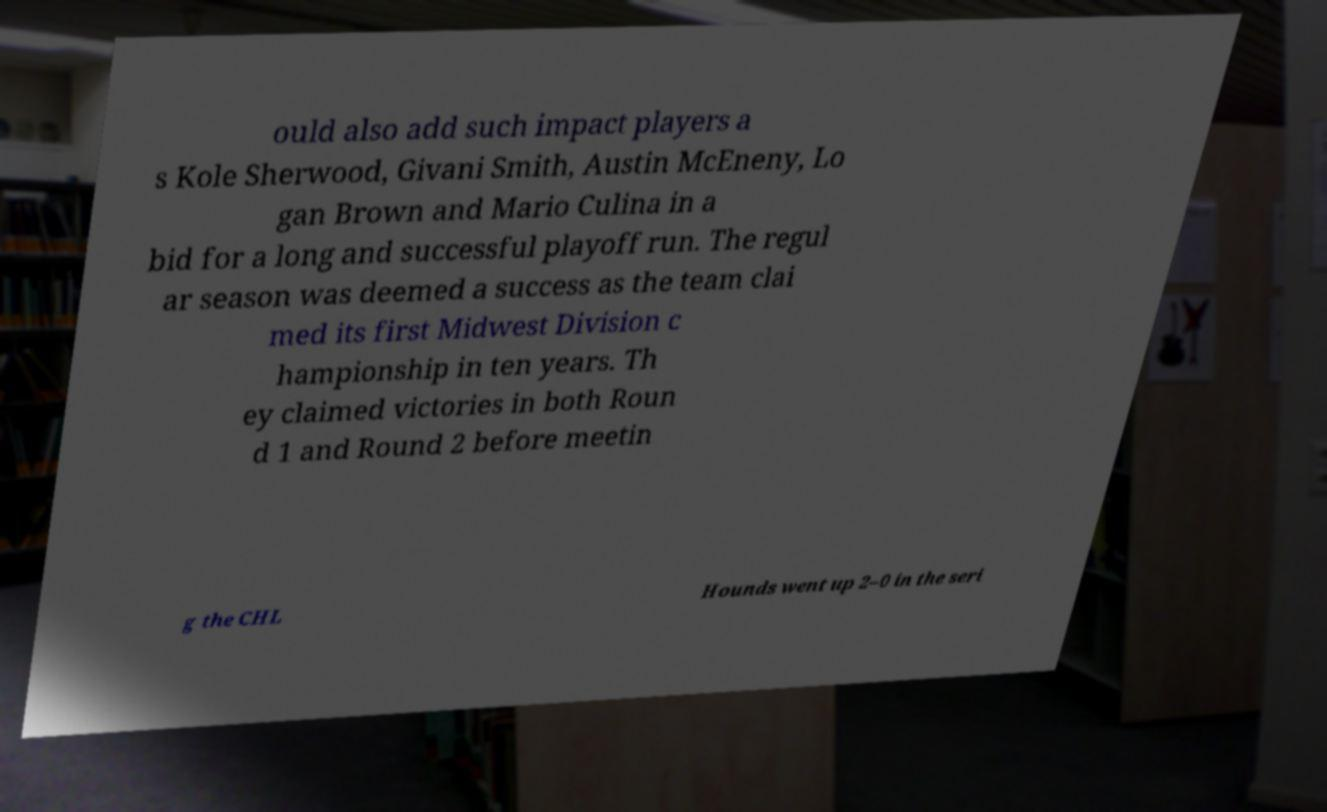Can you read and provide the text displayed in the image?This photo seems to have some interesting text. Can you extract and type it out for me? ould also add such impact players a s Kole Sherwood, Givani Smith, Austin McEneny, Lo gan Brown and Mario Culina in a bid for a long and successful playoff run. The regul ar season was deemed a success as the team clai med its first Midwest Division c hampionship in ten years. Th ey claimed victories in both Roun d 1 and Round 2 before meetin g the CHL Hounds went up 2–0 in the seri 